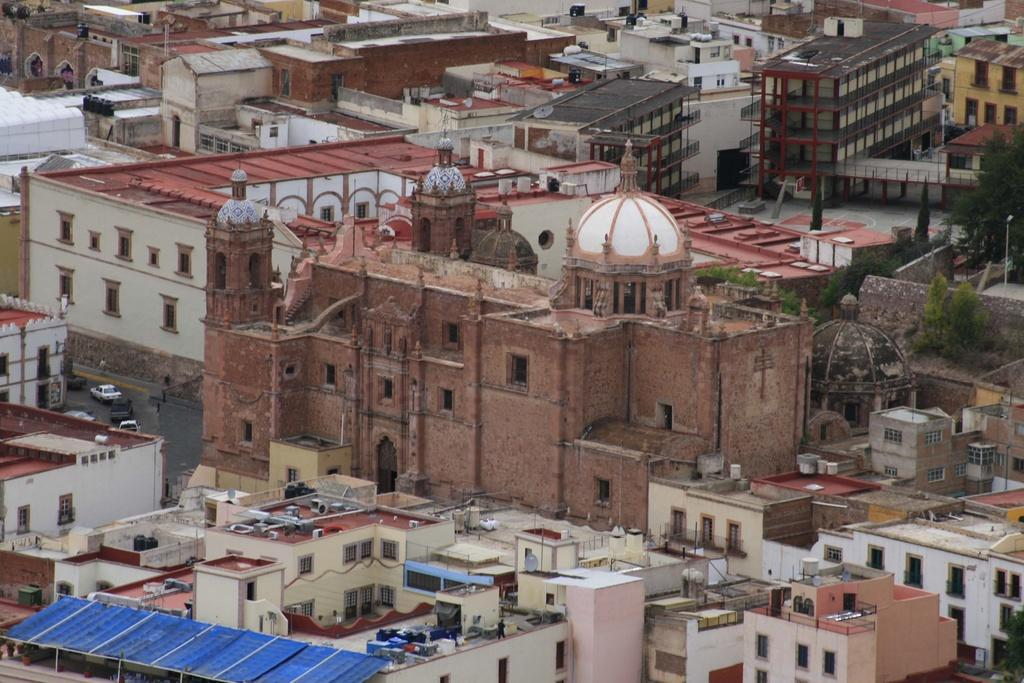What type of structures can be seen in the image? There are buildings in the image. What else is present in the image besides buildings? There are vehicles and trees in the image. Can you describe any specific features of the buildings? There are windows visible in the image. Where is the zoo located in the image? There is no zoo present in the image. What type of plant is growing near the buildings in the image? The provided facts do not mention any specific plants, so we cannot determine the type of plant growing near the buildings. 